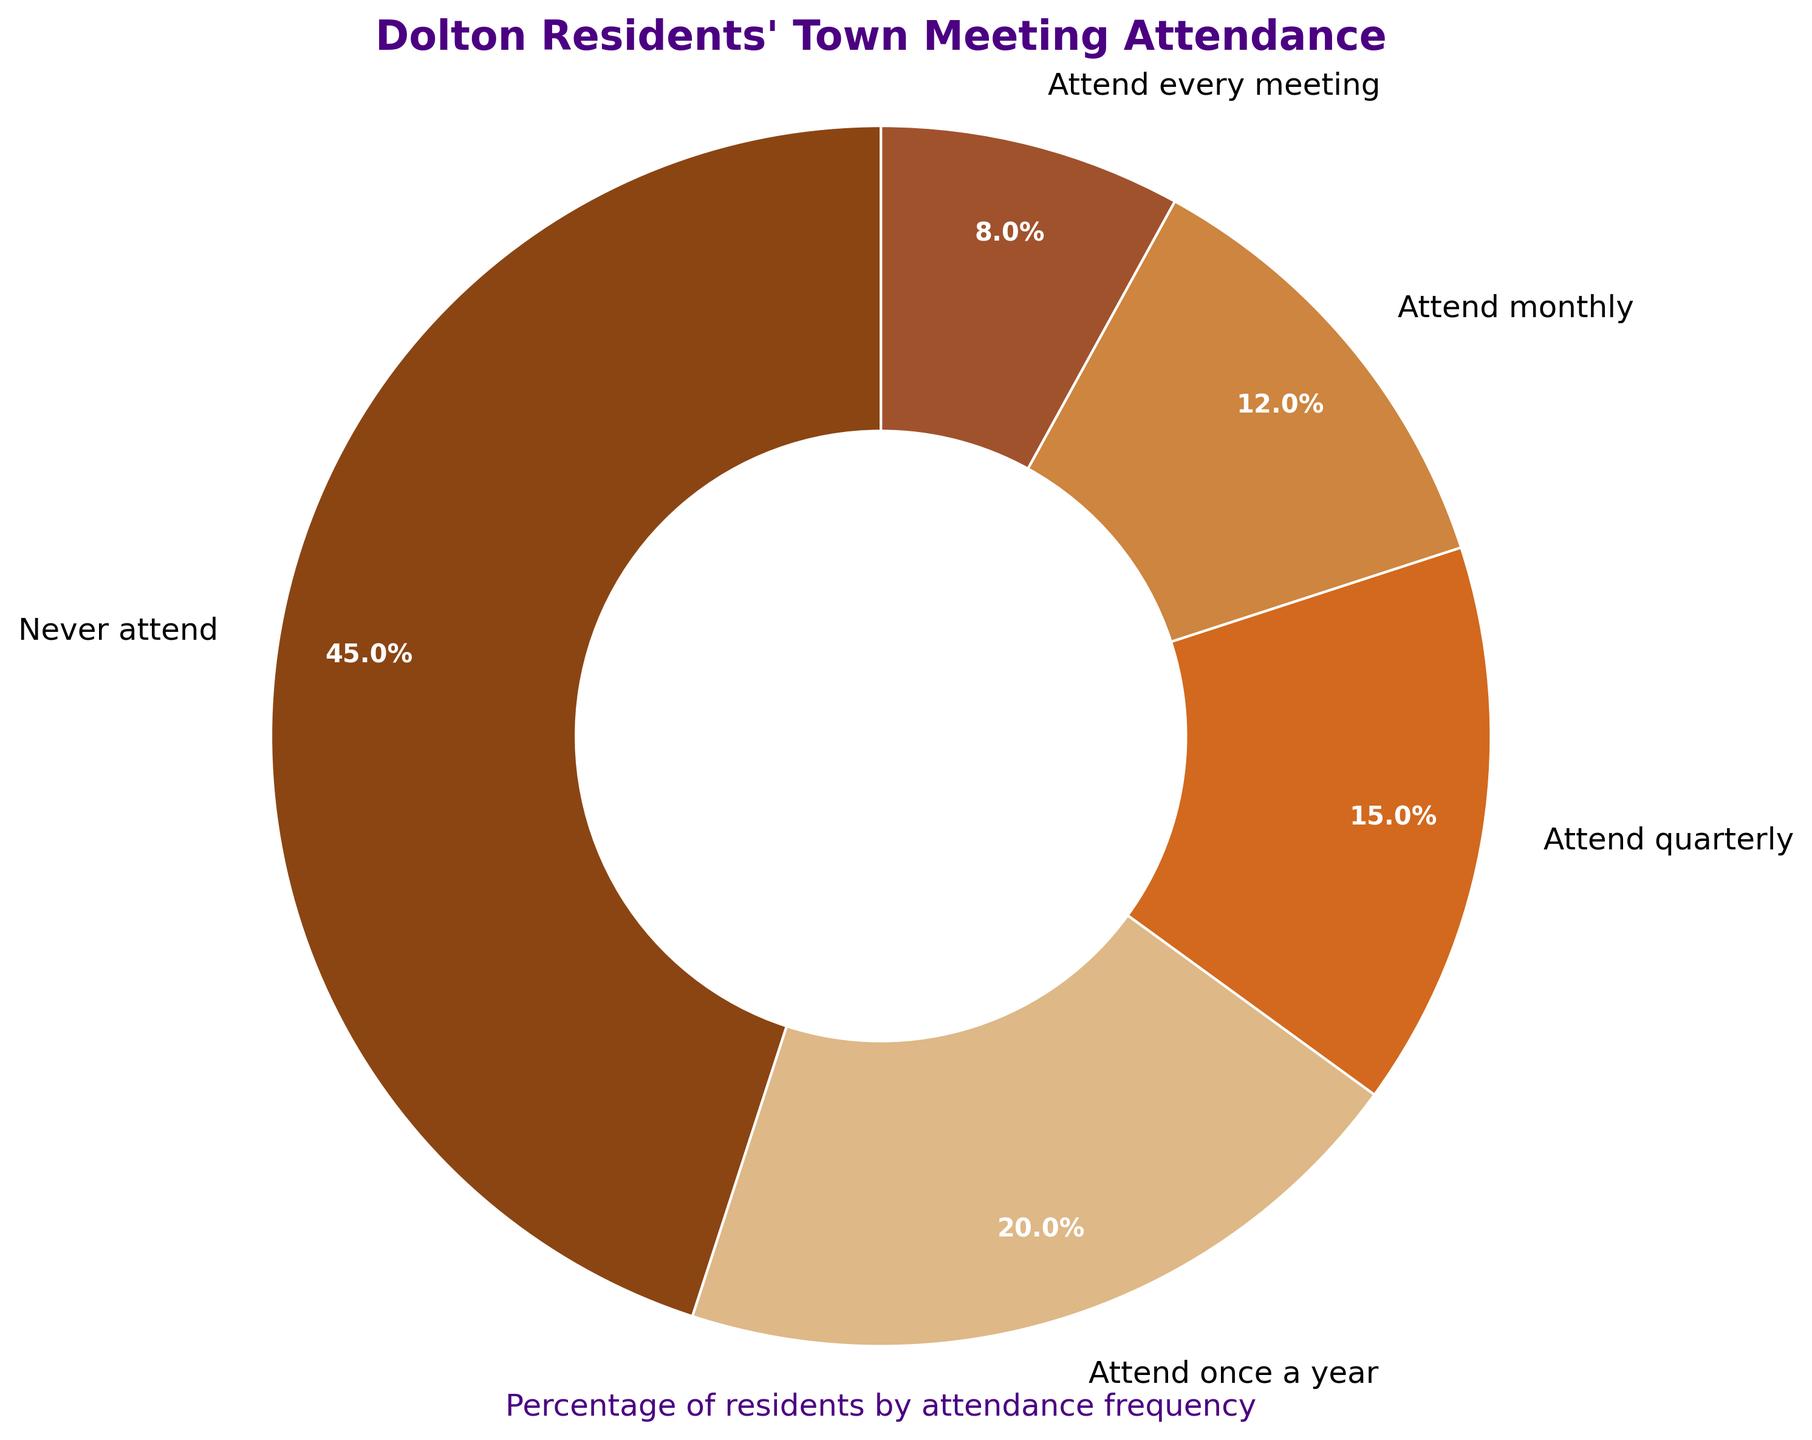What percentage of Dolton residents attend town meetings quarterly or more frequently? Add the percentages of residents who attend quarterly, monthly, and every meeting: 15% (quarterly) + 12% (monthly) + 8% (every meeting) = 35%
Answer: 35% Which frequency category has the highest attendance percentage? The largest slice on the pie chart represents residents who never attend town meetings, which is 45%
Answer: Never attend Do more residents attend town meetings once a year or quarterly? Compare the percentages of residents who attend once a year (20%) to those who attend quarterly (15%)
Answer: Once a year What is the difference in percentage between residents who never attend and those who attend every meeting? Subtract the percentage of residents who attend every meeting (8%) from the percentage of residents who never attend (45%): 45% - 8% = 37%
Answer: 37% How many frequency categories have an attendance percentage greater than 10%? The frequency categories with attendance percentages greater than 10% are "Never attend" (45%), "Attend once a year" (20%), "Attend quarterly" (15%), and "Attend monthly" (12%), totaling four categories
Answer: Four Which frequency category is represented by the darkest color on the pie chart? The darkest color, brown, corresponds to the "Never attend" category
Answer: Never attend What is the combined percentage of residents who attend town meetings at least once a year? Add the percentages of residents who attend at least once a year (20%), quarterly (15%), monthly (12%), and every meeting (8%): 20% + 15% + 12% + 8% = 55%
Answer: 55% Is the percentage of residents who attend monthly greater than those who attend every meeting? Compare the percentages: 12% (monthly) is greater than 8% (every meeting)
Answer: Yes Which frequency category has the smallest attendance percentage? The category with the smallest slice in the pie chart is "Attend every meeting" at 8%
Answer: Attend every meeting What percentage of residents does not attend meetings or only attends once a year? Add the percentages of "Never attend" (45%) and "Attend once a year" (20%): 45% + 20% = 65%
Answer: 65% 